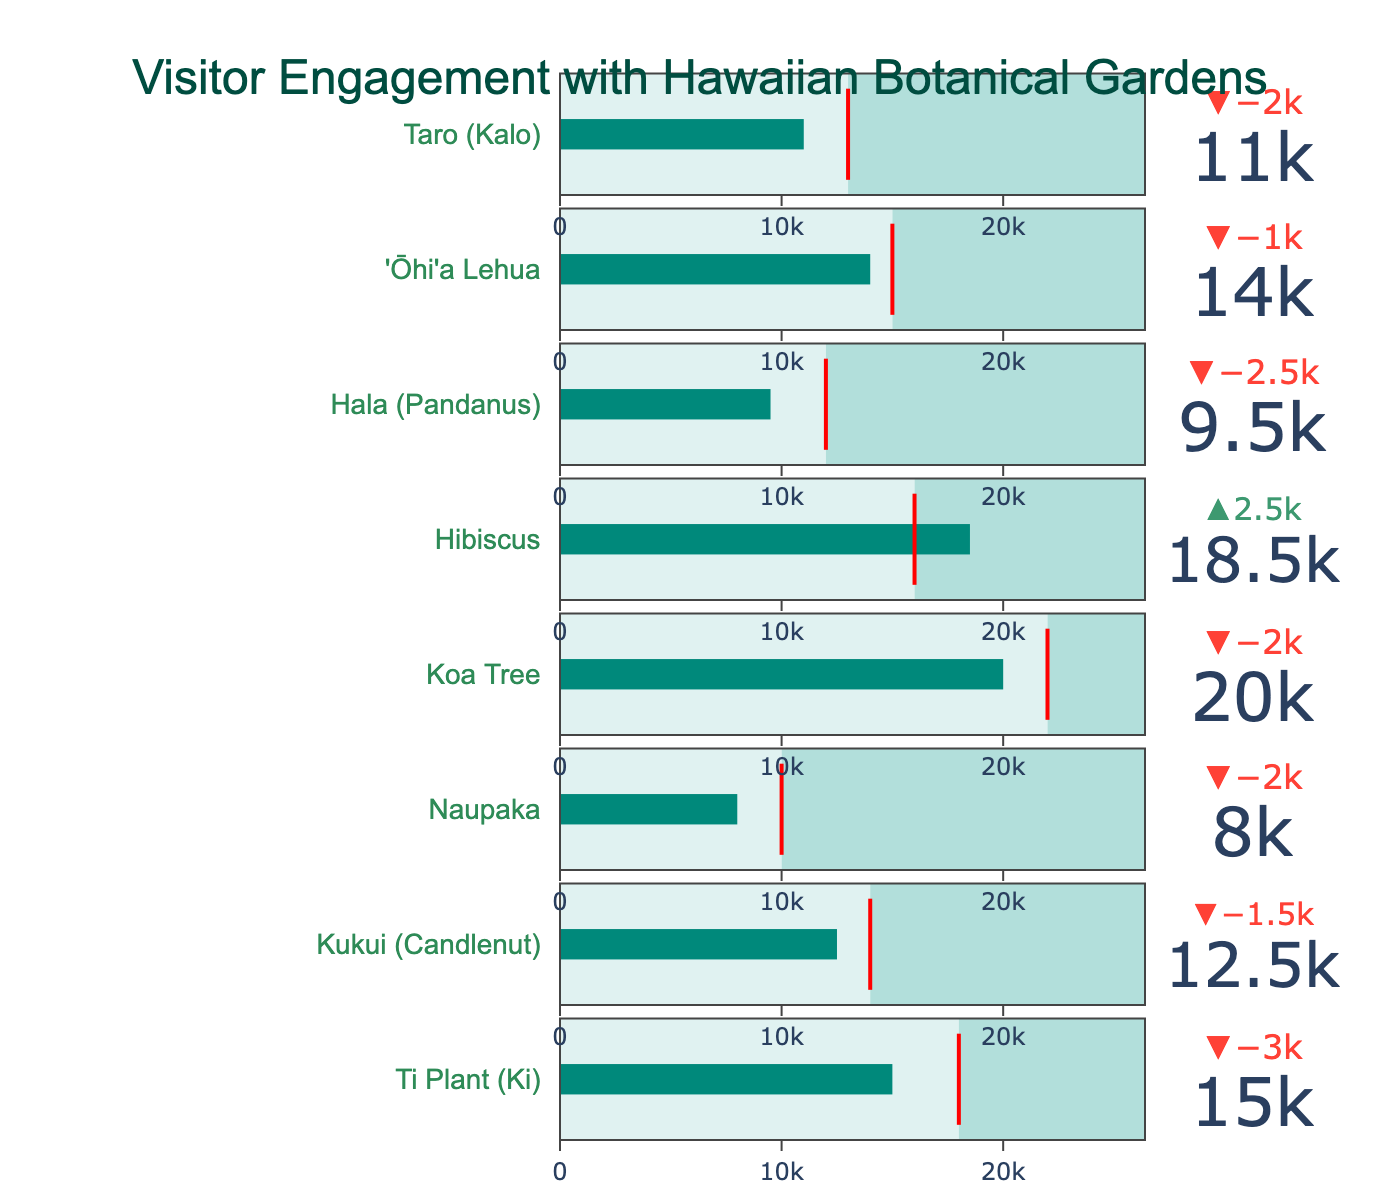Which plant exhibit has the highest number of actual visitors? The Koa Tree exhibit has the highest actual visitors in the figure.
Answer: Koa Tree How many visitors were targeted for the Ti Plant (Ki) exhibit? As shown by the red threshold line on the indicator for Ti Plant, the target visitors are 18,000.
Answer: 18,000 What is the difference between actual and target visitors for the Kukui (Candlenut) exhibit? The actual visitors for Kukui are 12,500, while the target is 14,000. The difference is 14,000 minus 12,500.
Answer: 1,500 Which exhibit exceeded its target visitor number, and by how much? The Hibiscus exhibit with 18,500 actual visitors exceeded its target of 16,000 by the difference, which is 2,500.
Answer: Hibiscus by 2,500 Which exhibits did not meet their target visitor numbers? By observing where the actual visitors fall short of the red threshold line, Ti Plant (Ki), Kukui (Candlenut), Naupaka, Koa Tree, Hala (Pandanus), and Taro (Kalo) exhibits did not meet their targets.
Answer: Ti Plant (Ki), Kukui (Candlenut), Naupaka, Koa Tree, Hala (Pandanus), Taro (Kalo) What's the average number of actual visitors across all the exhibits shown? Sum the actual visitors (15,000, 12,500, 8,000, 20,000, 18,500, 9,500, 14,000, 11,000) and divide by 8. The sum is 108,500, so the average is 108,500 / 8.
Answer: 13,562.5 Which exhibit has the greatest discrepancy where the actual visitors are less than the target visitors? The Koa Tree exhibit has actual visitors at 20,000 and target at 22,000, with the discrepancy being 22,000 minus 20,000, which is 2,000, the greatest shortfall in the figure.
Answer: Koa Tree by 2,000 What percentage of the target visitors did the Naupaka exhibit achieve? The Naupaka exhibit had 8,000 actual visitors and a target of 10,000. To find the percentage, (8,000 / 10,000) * 100%.
Answer: 80% Which exhibits hit exactly their target visitor number? No exhibit shows an actual visitors bar perfectly aligned with its target threshold line, indicating no exhibit hit exactly their target visitor number.
Answer: None 